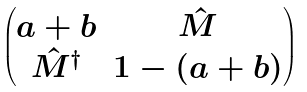<formula> <loc_0><loc_0><loc_500><loc_500>\begin{pmatrix} a + b & \hat { M } \\ \hat { M } ^ { \dagger } & 1 - ( a + b ) \end{pmatrix}</formula> 